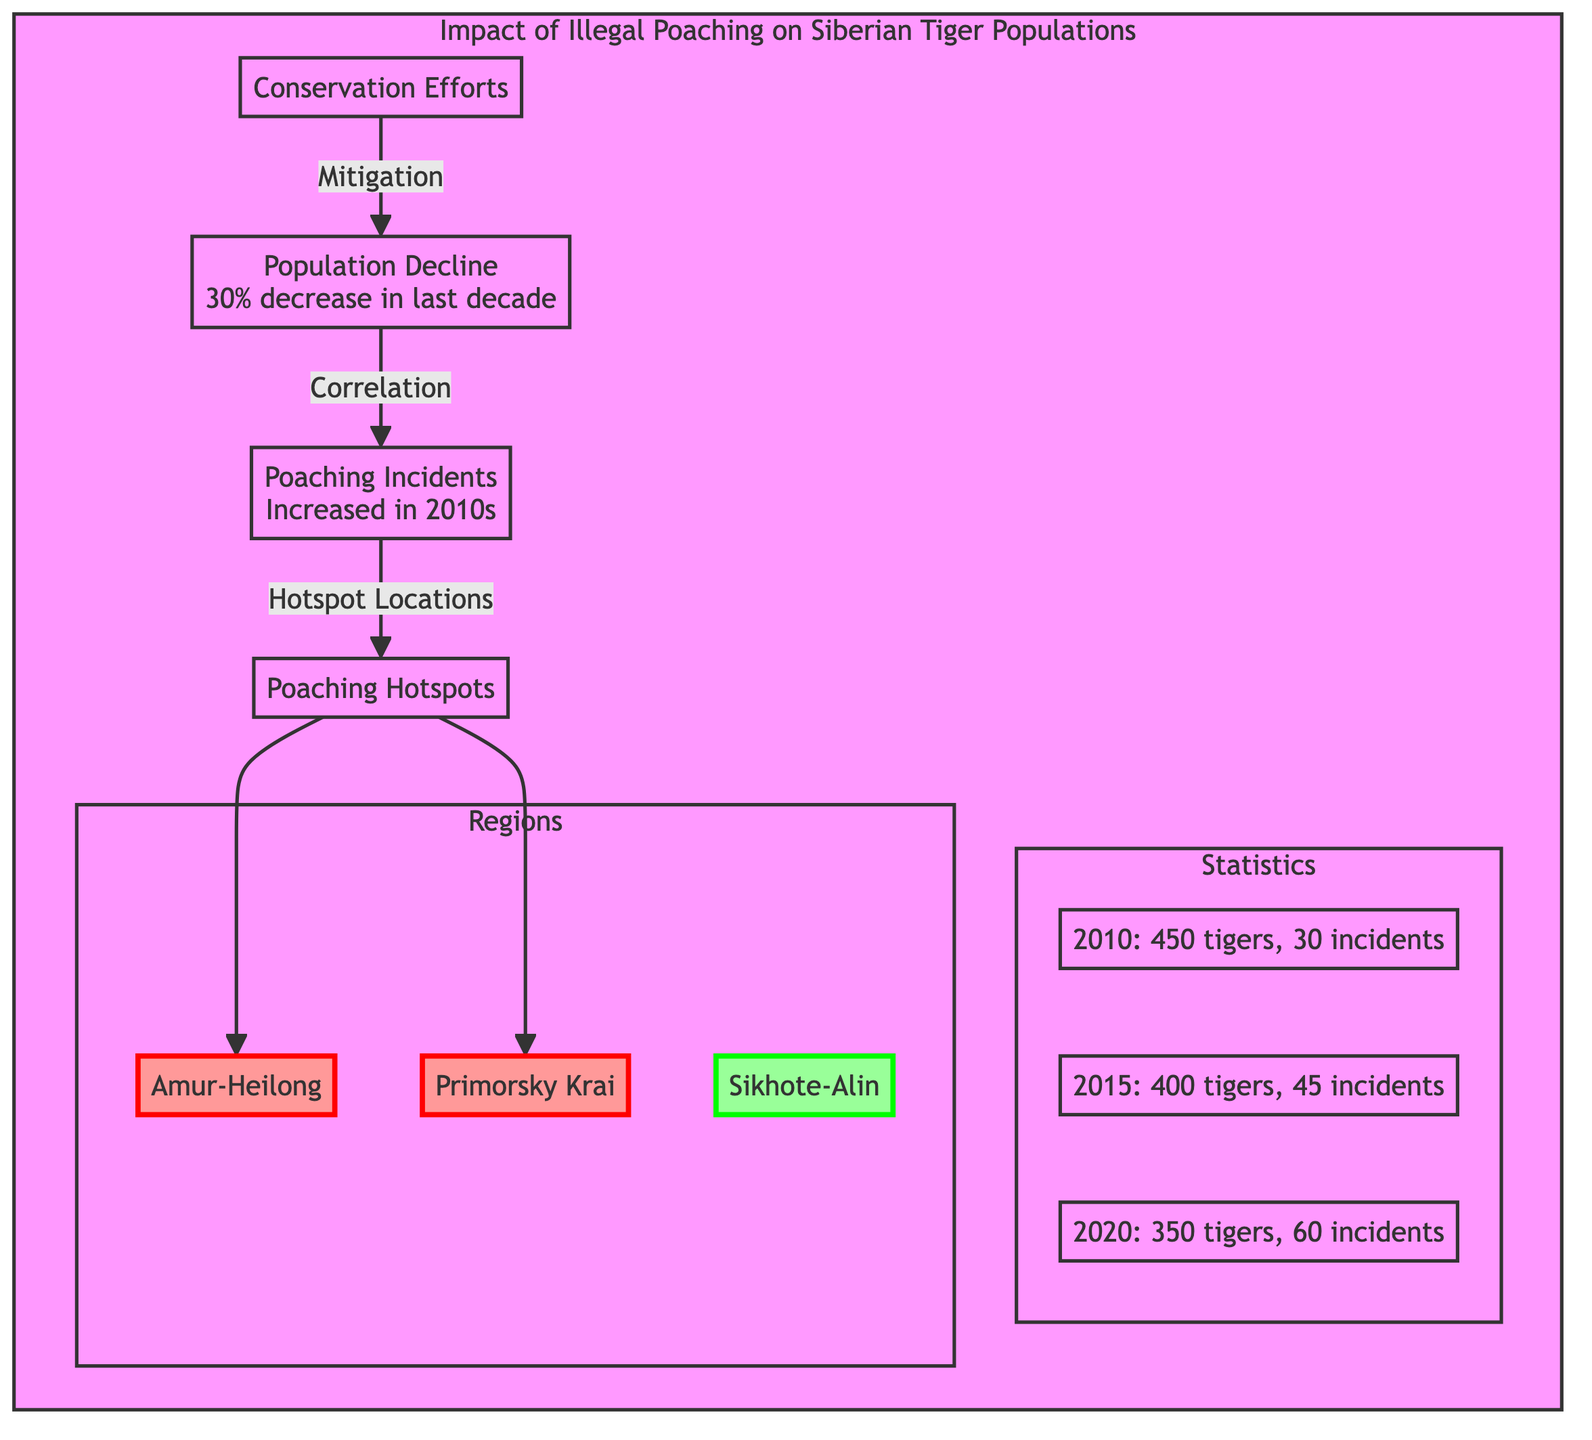What is the percentage decrease in tiger populations over the last decade? The diagram states that there has been a 30% decrease in the tiger population over the last decade, which is indicated in the node labeled "Population Decline."
Answer: 30% How many poaching incidents were recorded in 2015? In the statistics subgraph, the node for 2015 shows that there were 45 incidents recorded that year.
Answer: 45 incidents What is the total number of known tiger individuals in 2020? The statistics subgraph depicts that in 2020, there were 350 tigers, as indicated in the respective node.
Answer: 350 tigers Which regions are identified as poaching hotspots? The diagram illustrates that the identified hotspots include Amur-Heilong and Primorsky Krai, as shown in the nodes under "Regions."
Answer: Amur-Heilong, Primorsky Krai What correlation is shown between poaching incidents and tiger populations? The diagram indicates a correlation shown by the arrow from "Poaching Incidents" to "Population Decline," suggesting that increased poaching directly relates to the decline in tiger populations.
Answer: Increased poaching correlates with population decline How many incidents were reported in the year 2010? The statistics subgraph indicates that 30 incidents were reported in the year 2010, as stated in the respective node for that year.
Answer: 30 incidents What is the main impact of conservation efforts according to the diagram? The diagram illustrates that conservation efforts lead to the mitigation of population decline, as indicated by the arrow pointing from "Conservation Efforts" to "Population Decline."
Answer: Mitigation Which decade shows the highest increase in poaching incidents based on the diagram’s data? By comparing the incidents from 2010 (30), 2015 (45), and 2020 (60), it shows that the decade of the 2010s experienced the highest increase, particularly between 2015 and 2020.
Answer: 2010s How many total nodes are present in the "Statistics" subgraph? The "Statistics" subgraph contains three nodes representing the years 2010, 2015, and 2020. Counting these nodes provides the total number within that subgraph.
Answer: 3 nodes 